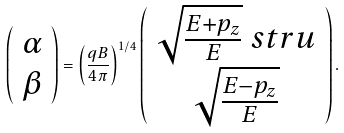<formula> <loc_0><loc_0><loc_500><loc_500>\left ( \begin{array} { c } \alpha \\ \beta \end{array} \right ) = \left ( \frac { q B } { 4 \pi } \right ) ^ { 1 / 4 } \left ( \begin{array} { c } \sqrt { \frac { E + p _ { z } } { E } } \ s t r u \\ \sqrt { \frac { E - p _ { z } } { E } } \end{array} \right ) .</formula> 